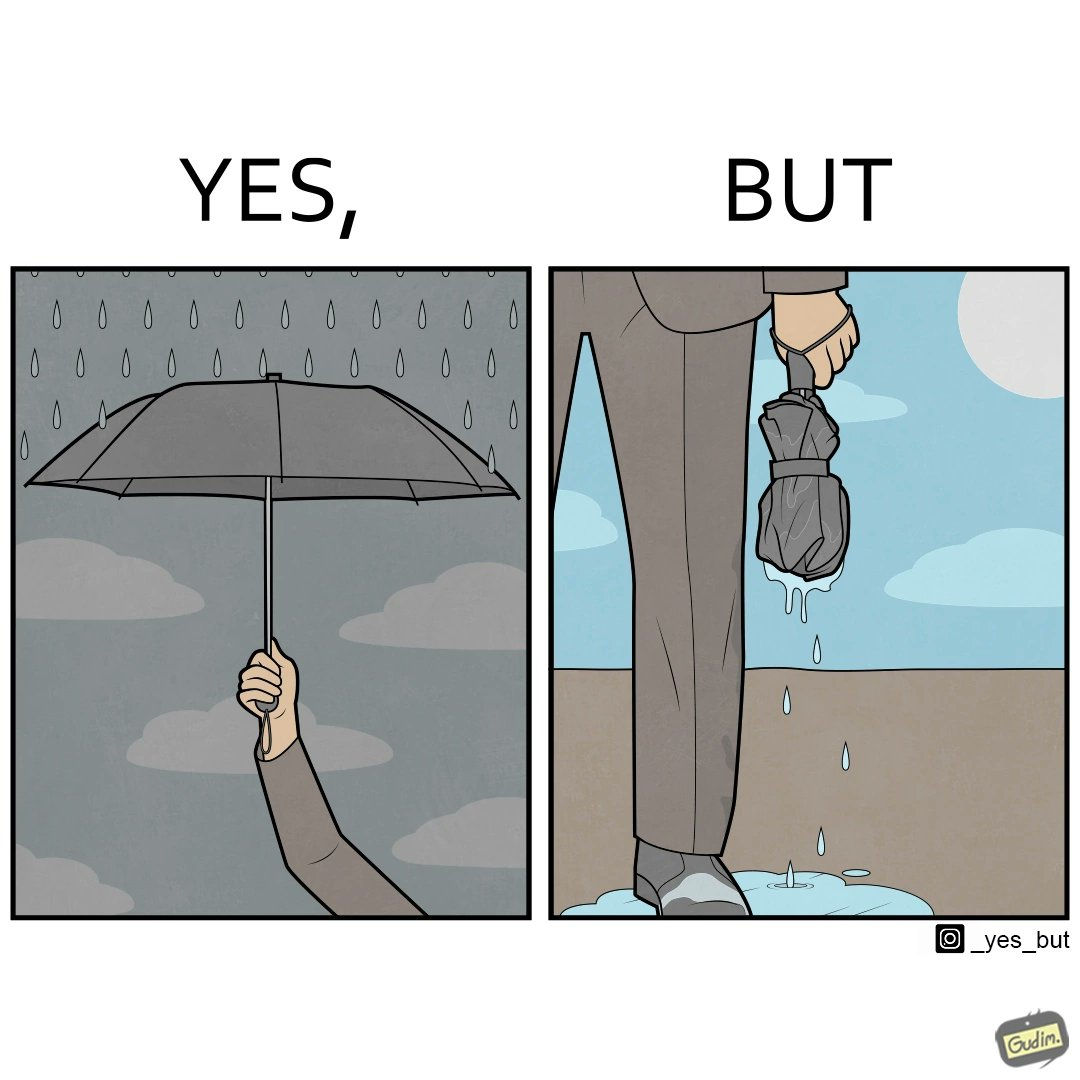What do you see in each half of this image? In the left part of the image: The image shows a hand holding an open black umbrella during rain. The open umbrella is stopping the raindrops to fall below it. In the right part of the image: The image shows water dripping from a wet, folded umberlla in a man's hand. The water is all over the man's shoe and the floor around it. 